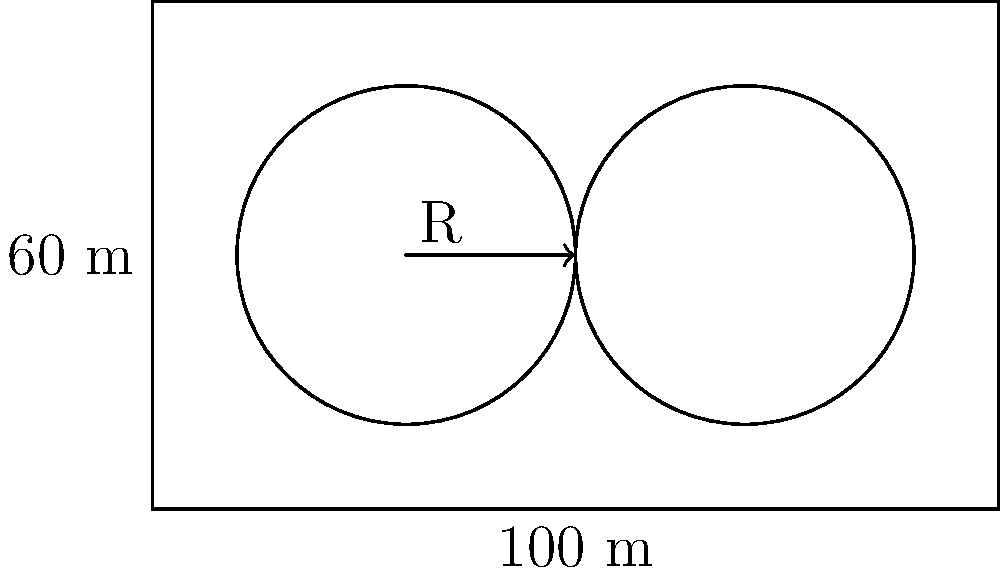A rectangular development site measures 100 meters by 60 meters. Two circular water retention ponds need to be placed within the site, each with a radius of 20 meters. The centers of the ponds should be equidistant from the long sides of the site and from each other. What is the maximum distance between the centers of the two ponds? Let's approach this step-by-step:

1) The ponds are equidistant from the long sides, so their centers will be on a line parallel to the long sides and halfway between them. This line is 30 meters from each long side (half of 60 meters).

2) Let's call the distance between the centers of the ponds $x$ meters.

3) The total width of the site is 100 meters. This width must accommodate:
   - The radius of the left pond (20 m)
   - The space between the ponds ($x$ m)
   - The radius of the right pond (20 m)

4) We can express this as an equation:
   $20 + x + 20 = 100$

5) Simplifying:
   $x + 40 = 100$
   $x = 60$

6) Therefore, the maximum distance between the centers of the two ponds is 60 meters.

7) We can verify that this leaves exactly 20 meters from each pond center to the nearest short side of the rectangle (as required for the pond to fit):
   $(100 - 60) / 2 = 20$
Answer: 60 meters 